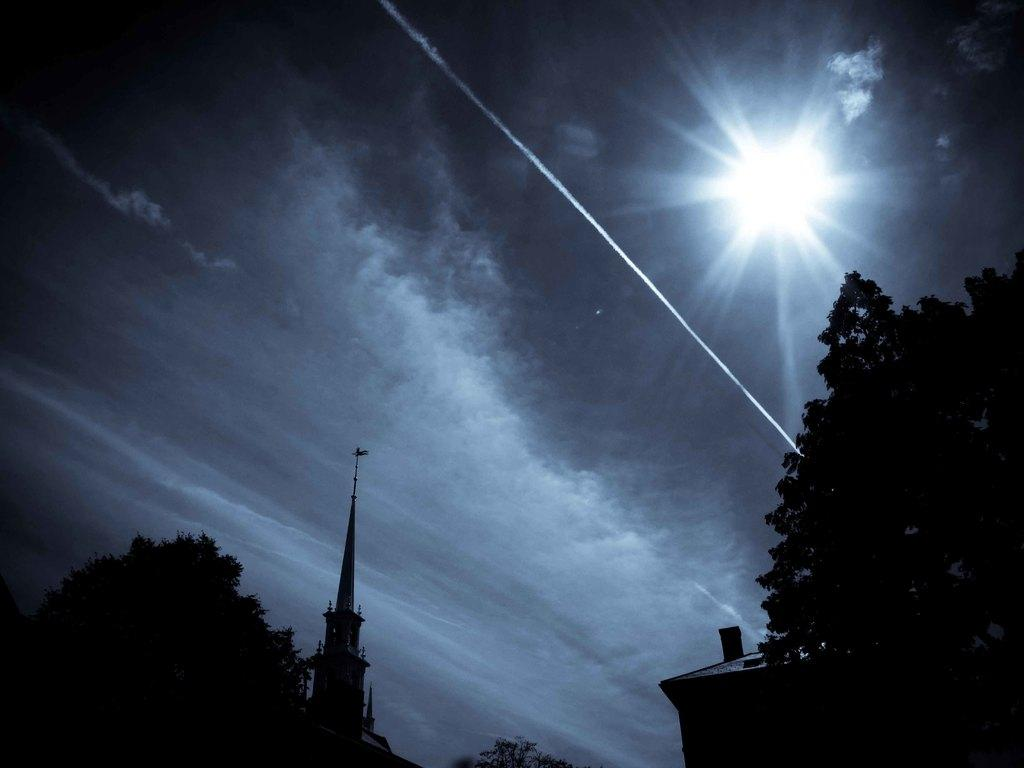What type of structure is present in the image? There is a building in the image. What other natural elements can be seen in the image? There are trees in the image. What additional architectural feature is visible? There is a tower in the image. What is the source of light at the top of the image? Sunlight is visible at the top of the image. What decision was made by the tree in the image? There is no decision made by the tree in the image, as trees do not have the ability to make decisions. Can you describe the road in the image? There is no road present in the image; it features a building, trees, and a tower. 